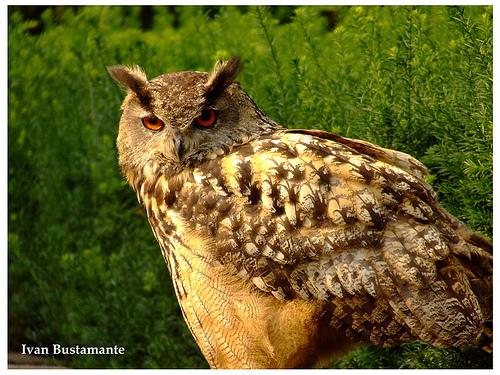What kind of bird is this?
Answer briefly. Owl. What kind of Owl is this?
Quick response, please. Barn. Does this animal eat meat?
Answer briefly. Yes. 